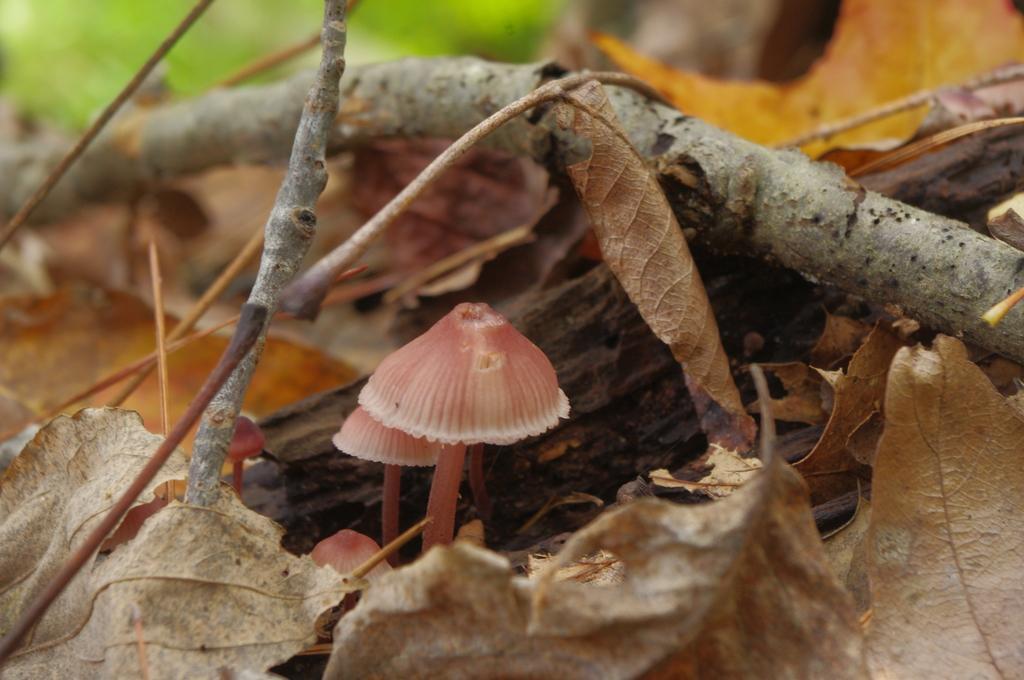Could you give a brief overview of what you see in this image? In the image there are few mushrooms and around the mushrooms there are wooden branches and dry leaves. 